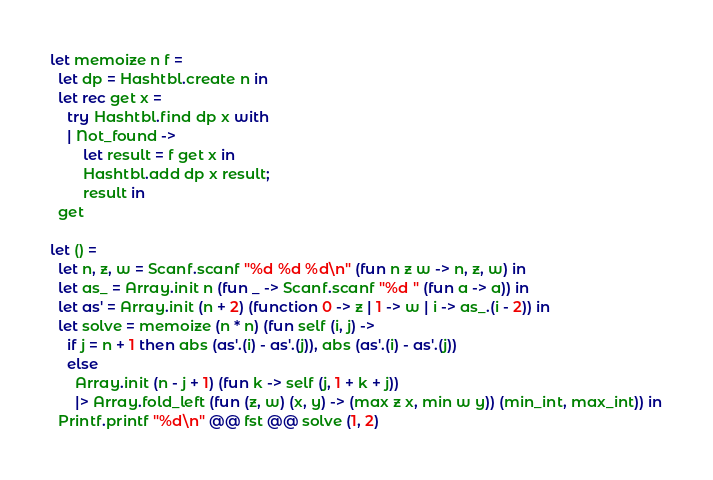Convert code to text. <code><loc_0><loc_0><loc_500><loc_500><_OCaml_>let memoize n f =
  let dp = Hashtbl.create n in
  let rec get x =
    try Hashtbl.find dp x with
    | Not_found ->
        let result = f get x in
        Hashtbl.add dp x result;
        result in
  get

let () =
  let n, z, w = Scanf.scanf "%d %d %d\n" (fun n z w -> n, z, w) in
  let as_ = Array.init n (fun _ -> Scanf.scanf "%d " (fun a -> a)) in
  let as' = Array.init (n + 2) (function 0 -> z | 1 -> w | i -> as_.(i - 2)) in
  let solve = memoize (n * n) (fun self (i, j) ->
    if j = n + 1 then abs (as'.(i) - as'.(j)), abs (as'.(i) - as'.(j))
    else
      Array.init (n - j + 1) (fun k -> self (j, 1 + k + j))
      |> Array.fold_left (fun (z, w) (x, y) -> (max z x, min w y)) (min_int, max_int)) in
  Printf.printf "%d\n" @@ fst @@ solve (1, 2)</code> 